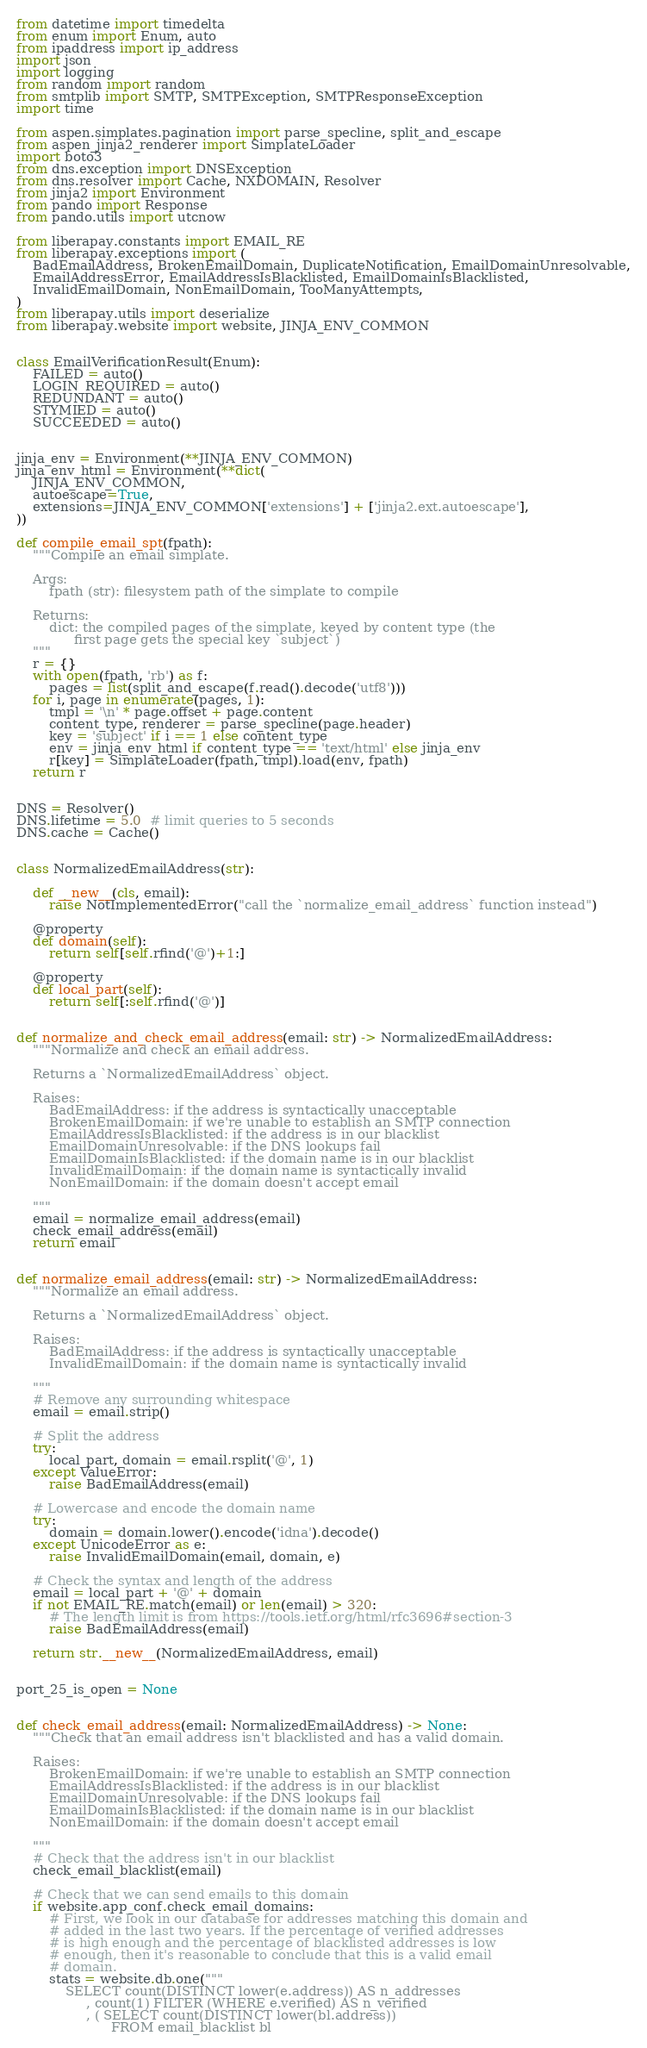Convert code to text. <code><loc_0><loc_0><loc_500><loc_500><_Python_>from datetime import timedelta
from enum import Enum, auto
from ipaddress import ip_address
import json
import logging
from random import random
from smtplib import SMTP, SMTPException, SMTPResponseException
import time

from aspen.simplates.pagination import parse_specline, split_and_escape
from aspen_jinja2_renderer import SimplateLoader
import boto3
from dns.exception import DNSException
from dns.resolver import Cache, NXDOMAIN, Resolver
from jinja2 import Environment
from pando import Response
from pando.utils import utcnow

from liberapay.constants import EMAIL_RE
from liberapay.exceptions import (
    BadEmailAddress, BrokenEmailDomain, DuplicateNotification, EmailDomainUnresolvable,
    EmailAddressError, EmailAddressIsBlacklisted, EmailDomainIsBlacklisted,
    InvalidEmailDomain, NonEmailDomain, TooManyAttempts,
)
from liberapay.utils import deserialize
from liberapay.website import website, JINJA_ENV_COMMON


class EmailVerificationResult(Enum):
    FAILED = auto()
    LOGIN_REQUIRED = auto()
    REDUNDANT = auto()
    STYMIED = auto()
    SUCCEEDED = auto()


jinja_env = Environment(**JINJA_ENV_COMMON)
jinja_env_html = Environment(**dict(
    JINJA_ENV_COMMON,
    autoescape=True,
    extensions=JINJA_ENV_COMMON['extensions'] + ['jinja2.ext.autoescape'],
))

def compile_email_spt(fpath):
    """Compile an email simplate.

    Args:
        fpath (str): filesystem path of the simplate to compile

    Returns:
        dict: the compiled pages of the simplate, keyed by content type (the
              first page gets the special key `subject`)
    """
    r = {}
    with open(fpath, 'rb') as f:
        pages = list(split_and_escape(f.read().decode('utf8')))
    for i, page in enumerate(pages, 1):
        tmpl = '\n' * page.offset + page.content
        content_type, renderer = parse_specline(page.header)
        key = 'subject' if i == 1 else content_type
        env = jinja_env_html if content_type == 'text/html' else jinja_env
        r[key] = SimplateLoader(fpath, tmpl).load(env, fpath)
    return r


DNS = Resolver()
DNS.lifetime = 5.0  # limit queries to 5 seconds
DNS.cache = Cache()


class NormalizedEmailAddress(str):

    def __new__(cls, email):
        raise NotImplementedError("call the `normalize_email_address` function instead")

    @property
    def domain(self):
        return self[self.rfind('@')+1:]

    @property
    def local_part(self):
        return self[:self.rfind('@')]


def normalize_and_check_email_address(email: str) -> NormalizedEmailAddress:
    """Normalize and check an email address.

    Returns a `NormalizedEmailAddress` object.

    Raises:
        BadEmailAddress: if the address is syntactically unacceptable
        BrokenEmailDomain: if we're unable to establish an SMTP connection
        EmailAddressIsBlacklisted: if the address is in our blacklist
        EmailDomainUnresolvable: if the DNS lookups fail
        EmailDomainIsBlacklisted: if the domain name is in our blacklist
        InvalidEmailDomain: if the domain name is syntactically invalid
        NonEmailDomain: if the domain doesn't accept email

    """
    email = normalize_email_address(email)
    check_email_address(email)
    return email


def normalize_email_address(email: str) -> NormalizedEmailAddress:
    """Normalize an email address.

    Returns a `NormalizedEmailAddress` object.

    Raises:
        BadEmailAddress: if the address is syntactically unacceptable
        InvalidEmailDomain: if the domain name is syntactically invalid

    """
    # Remove any surrounding whitespace
    email = email.strip()

    # Split the address
    try:
        local_part, domain = email.rsplit('@', 1)
    except ValueError:
        raise BadEmailAddress(email)

    # Lowercase and encode the domain name
    try:
        domain = domain.lower().encode('idna').decode()
    except UnicodeError as e:
        raise InvalidEmailDomain(email, domain, e)

    # Check the syntax and length of the address
    email = local_part + '@' + domain
    if not EMAIL_RE.match(email) or len(email) > 320:
        # The length limit is from https://tools.ietf.org/html/rfc3696#section-3
        raise BadEmailAddress(email)

    return str.__new__(NormalizedEmailAddress, email)


port_25_is_open = None


def check_email_address(email: NormalizedEmailAddress) -> None:
    """Check that an email address isn't blacklisted and has a valid domain.

    Raises:
        BrokenEmailDomain: if we're unable to establish an SMTP connection
        EmailAddressIsBlacklisted: if the address is in our blacklist
        EmailDomainUnresolvable: if the DNS lookups fail
        EmailDomainIsBlacklisted: if the domain name is in our blacklist
        NonEmailDomain: if the domain doesn't accept email

    """
    # Check that the address isn't in our blacklist
    check_email_blacklist(email)

    # Check that we can send emails to this domain
    if website.app_conf.check_email_domains:
        # First, we look in our database for addresses matching this domain and
        # added in the last two years. If the percentage of verified addresses
        # is high enough and the percentage of blacklisted addresses is low
        # enough, then it's reasonable to conclude that this is a valid email
        # domain.
        stats = website.db.one("""
            SELECT count(DISTINCT lower(e.address)) AS n_addresses
                 , count(1) FILTER (WHERE e.verified) AS n_verified
                 , ( SELECT count(DISTINCT lower(bl.address))
                       FROM email_blacklist bl</code> 